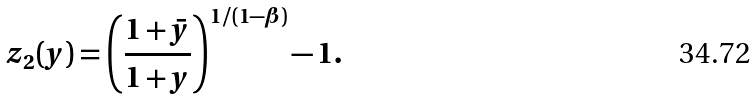Convert formula to latex. <formula><loc_0><loc_0><loc_500><loc_500>z _ { 2 } ( y ) = \left ( \frac { 1 + \bar { y } } { 1 + y } \right ) ^ { 1 / ( 1 - \beta ) } - 1 .</formula> 